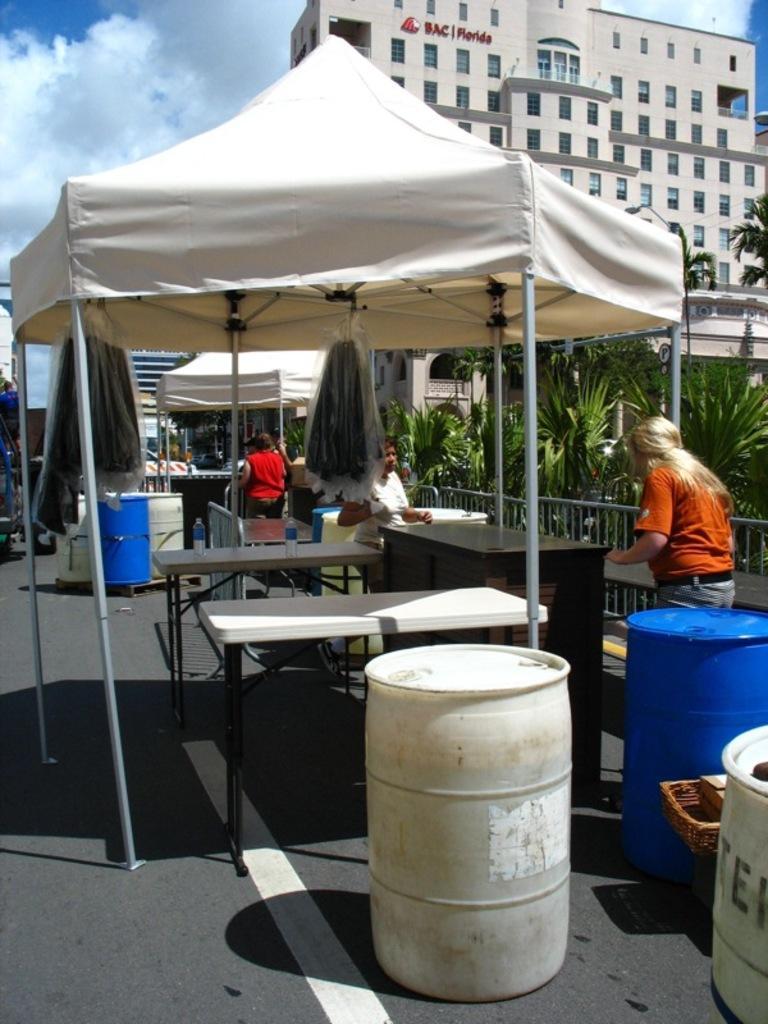Could you give a brief overview of what you see in this image? On the right there is a women who is wearing a orange color t-shirt and she is beside the desk. On the center we can see a two white tables. There are two barrels in white and blue color. On the top right corner we can see a building. On the left there is a sky with some clouds. And here it's a tent. On the background there is a person who is wearing a white color shirt. On the right there is a plants and tree. 